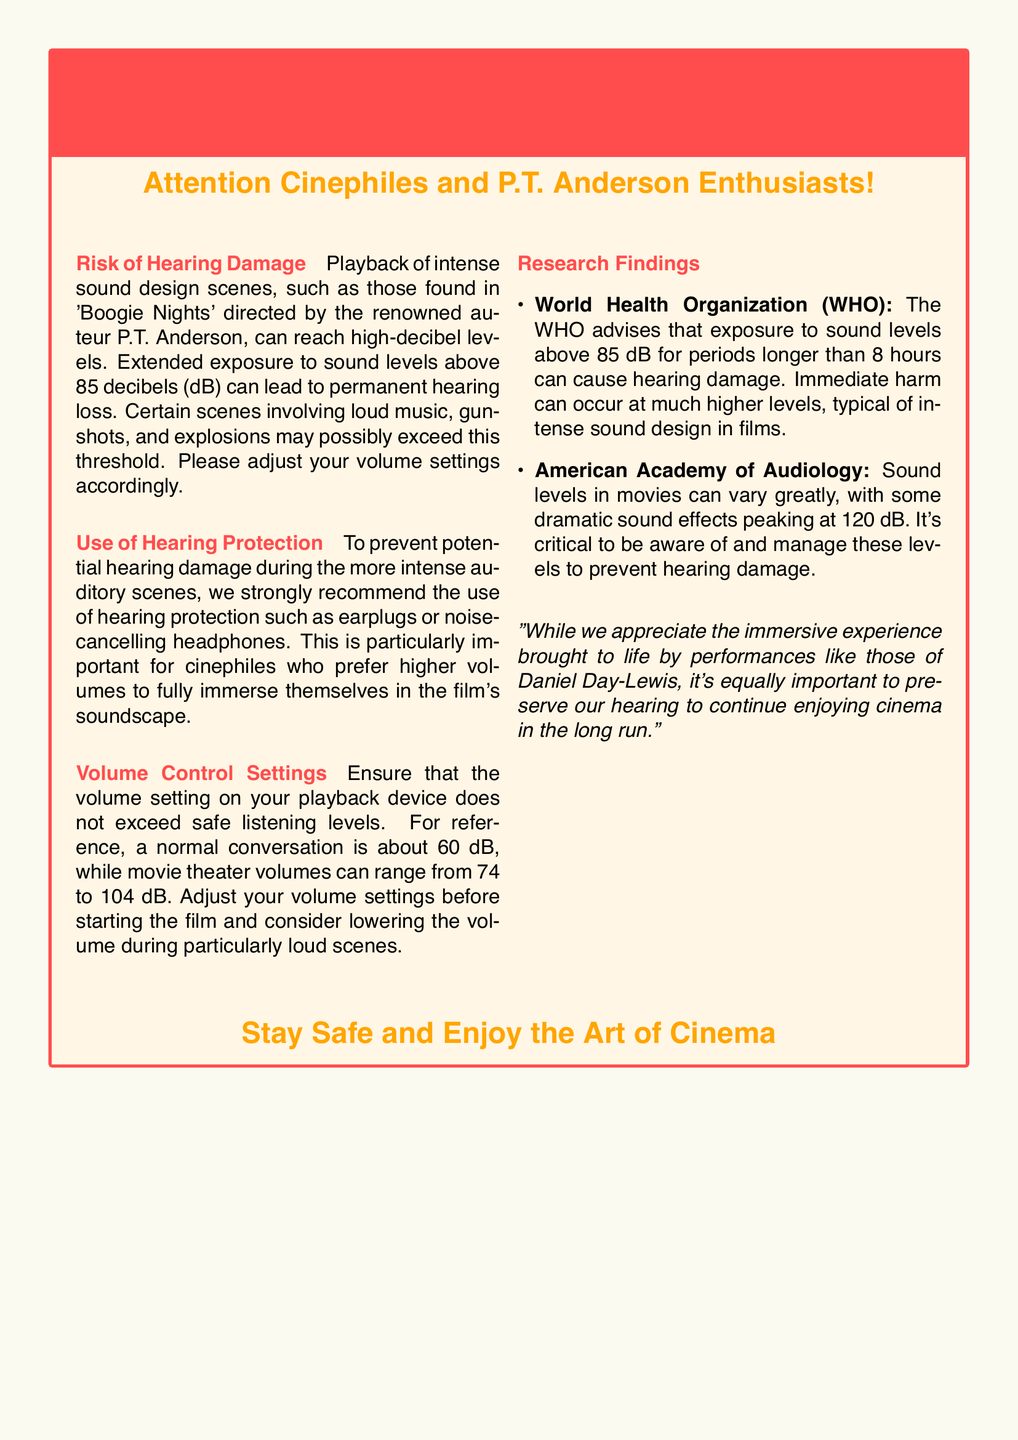What is the main risk mentioned? The main risk mentioned in the document is related to sound levels that can lead to permanent hearing loss during playback of intense sound design.
Answer: Hearing Damage What is the recommended use for protection? The document advises using hearing protection to prevent potential hearing damage during intense auditory scenes.
Answer: Hearing protection What is the safe sound level threshold? The document specifies that sound levels above 85 decibels can lead to hearing loss.
Answer: 85 decibels Which organization provides advice on sound levels? The document references the World Health Organization regarding sound level exposure guidelines.
Answer: World Health Organization What peak decibel level can movie sound effects reach? The document mentions that dramatic sound effects in movies can peak at 120 decibels.
Answer: 120 decibels Why should you adjust your volume settings? Adjusting volume settings is important to ensure they do not exceed safe listening levels during loud scenes.
Answer: Prevent hearing damage What is the average decibel level of a normal conversation? The document states that the average decibel level of a normal conversation is about 60 dB.
Answer: 60 dB What does the document suggest for those who prefer higher volumes? The document suggests using hearing protection for those who prefer higher volumes to fully immerse in the film's soundscape.
Answer: Use hearing protection What performance is appreciated regarding the immersive experience? The document appreciates the performances brought to life by Daniel Day-Lewis as part of the immersive experience in cinema.
Answer: Daniel Day-Lewis 